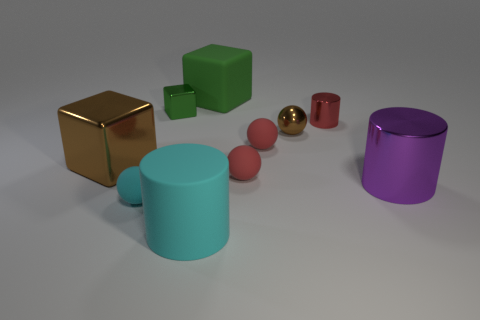Can you describe the lighting in this scene? The scene is moderately lit with a soft, diffused light that casts gentle shadows to the right of the objects, suggesting a light source from the top left side outside of the frame. The shadows are soft-edged and not overly pronounced, indicating that the light source is not extremely close to the objects. The even lighting enhances the colors and the different textures of the objects, giving the scene a calm and balanced feel. 